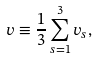Convert formula to latex. <formula><loc_0><loc_0><loc_500><loc_500>v \equiv \frac { 1 } { 3 } \sum _ { s = 1 } ^ { 3 } v _ { s } ,</formula> 